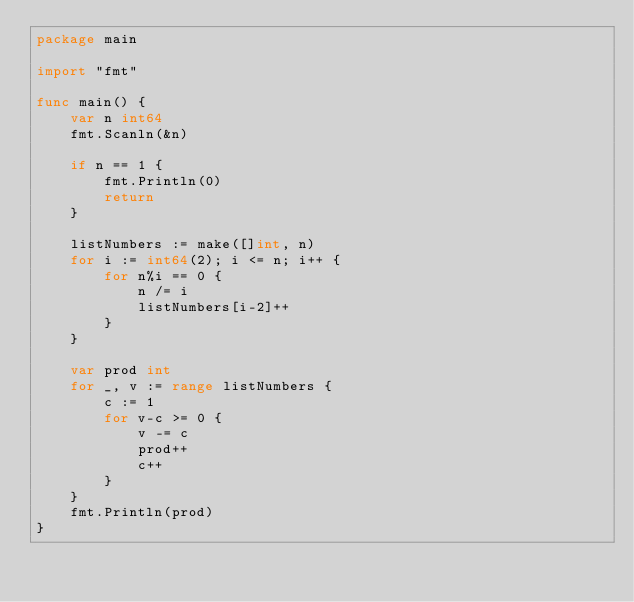<code> <loc_0><loc_0><loc_500><loc_500><_Go_>package main

import "fmt"

func main() {
	var n int64
	fmt.Scanln(&n)

	if n == 1 {
		fmt.Println(0)
		return
	}

	listNumbers := make([]int, n)
	for i := int64(2); i <= n; i++ {
		for n%i == 0 {
			n /= i
			listNumbers[i-2]++
		}
	}

	var prod int
	for _, v := range listNumbers {
		c := 1
		for v-c >= 0 {
			v -= c
			prod++
			c++
		}
	}
	fmt.Println(prod)
}
</code> 